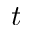Convert formula to latex. <formula><loc_0><loc_0><loc_500><loc_500>t</formula> 